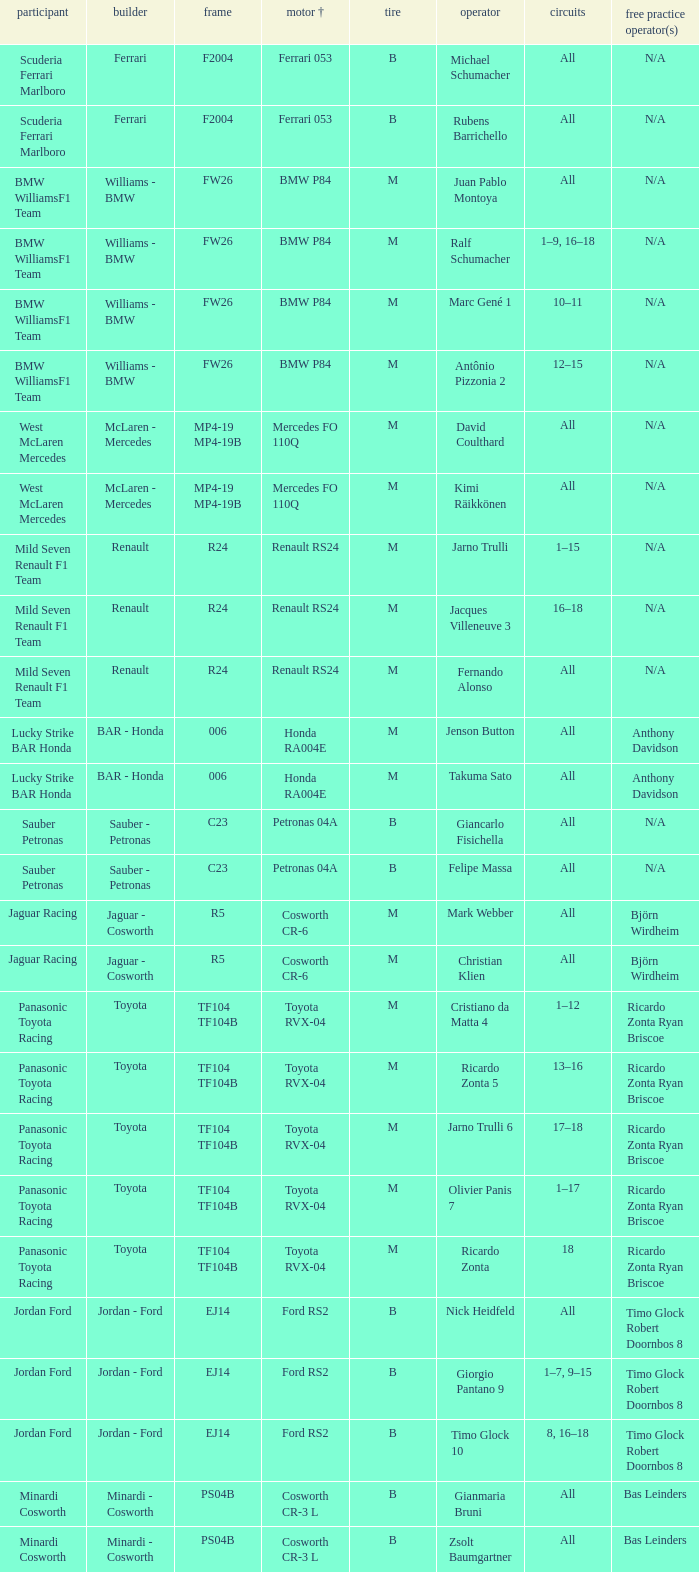What are the rounds for the B tyres and Ferrari 053 engine +? All, All. 